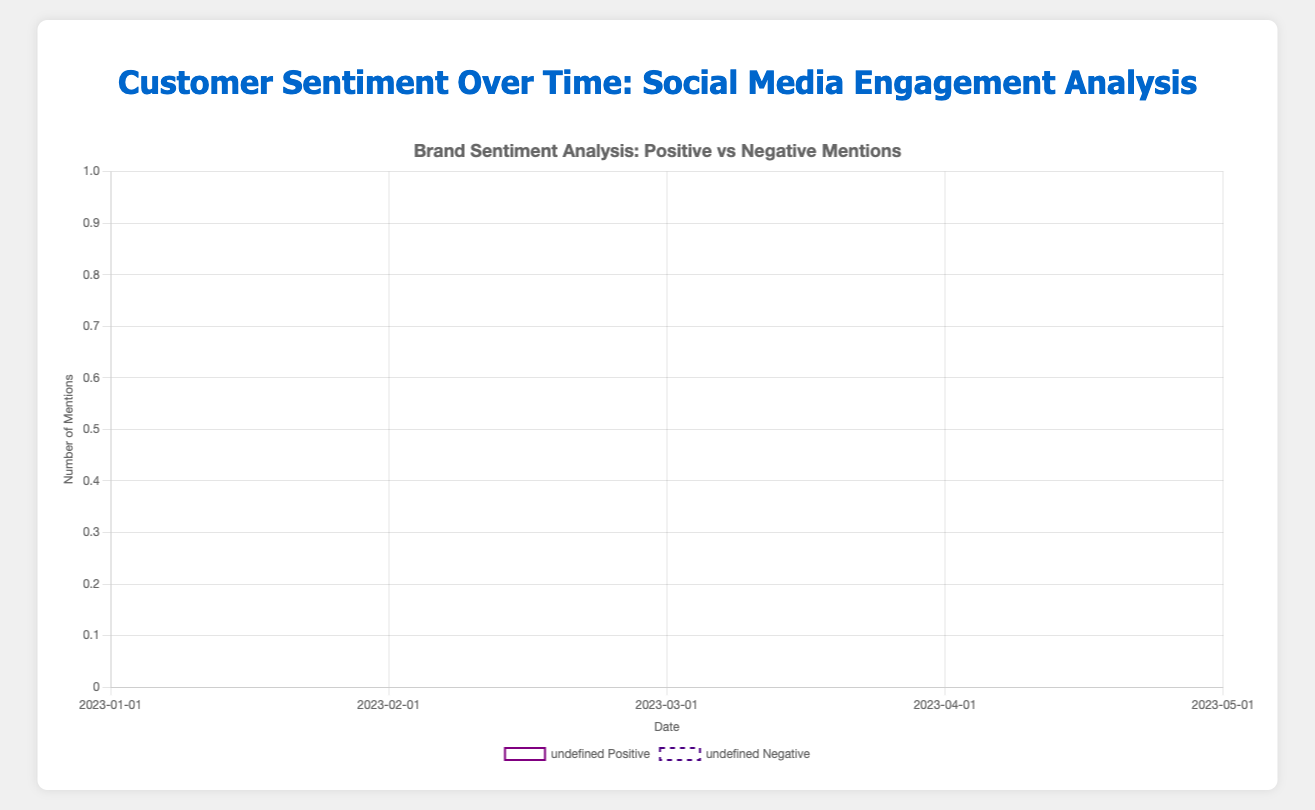What's the overall trend for Nike's positive mentions over the months? Observing Nike’s positive mentions: January (1520), February (1620), March (1735), April (1800), May (1905). There is a clear increasing trend in positive mentions each month.
Answer: Increasing Which brand had the highest amount of negative mentions in March? In March, Nike had 310 negative mentions, Adidas had 325, Puma had 145, and Under Armour had 190. Therefore, Adidas had the highest amount.
Answer: Adidas Between Adidas and Puma, which brand had a greater increase in positive mentions from January to May? For Adidas, positive mentions increased from 1400 to 1655 (an increase of 255). For Puma, positive mentions increased from 950 to 1200 (an increase of 250). Hence, Adidas had a slightly greater increase.
Answer: Adidas What is the average number of neutral mentions for Under Armour over the months provided? Summing up the neutral mentions for Under Armour: 300 + 320 + 330 + 340 + 350 = 1640. Dividing by the number of months (5), the average is 1640/5 = 328.
Answer: 328 Which brand had the most consistent number of negative mentions between January and May, and how can you tell? Reviewing the trends:
   - Nike: 320, 295, 310, 280, 310
   - Adidas: 350, 340, 325, 300, 320
   - Puma: 150, 160, 145, 140, 130
   - Under Armour: 220, 210, 190, 180, 175
Puma's numbers are decreasing gradually without large fluctuations, indicating most consistency.
Answer: Puma How did the number of positive mentions in January compare among all the brands? January positive mentions were Nike: 1520, Adidas: 1400, Puma: 950, Under Armour: 680. Therefore, Nike had the highest number of positive mentions, followed by Adidas, Puma, and Under Armour.
Answer: Nike > Adidas > Puma > Under Armour Comparing April, which brand had the highest total engagement (sum of positive, negative, and neutral mentions)? Summing up the mentions in April for each brand:
   - Nike: 1800 + 280 + 640 = 2720
   - Adidas: 1600 + 300 + 620 = 2520
   - Puma: 1125 + 140 + 495 = 1760
   - Under Armour: 780 + 180 + 340 = 1300
Nike had the highest total engagement.
Answer: Nike In terms of positive mentions, which brand showed the smallest increase from February to March? The increases in positive mentions from February to March:
   - Nike: 1735 - 1620 = 115
   - Adidas: 1530 - 1475 = 55
   - Puma: 1080 - 1020 = 60
   - Under Armour: 750 - 720 = 30
Under Armour had the smallest increase.
Answer: Under Armour Which color line represents the trend of negative mentions for Adidas and how can you identify it? The color line for Adidas’ negative mentions is noted as a dashed line in blue. This can be identified by looking for the dashed blue line in the chart, which corresponds to Adidas brand’s negative mentions trend.
Answer: Dashed blue line 